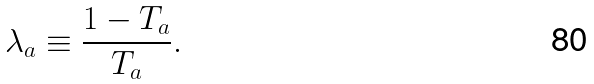Convert formula to latex. <formula><loc_0><loc_0><loc_500><loc_500>\lambda _ { a } \equiv \frac { 1 - T _ { a } } { T _ { a } } .</formula> 